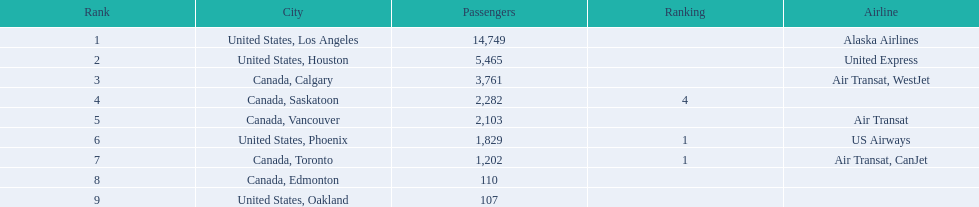What were the total passenger figures? 14,749, 5,465, 3,761, 2,282, 2,103, 1,829, 1,202, 110, 107. Which of these were bound for los angeles? 14,749. What other destination, together with this, is almost 19,000? Canada, Calgary. Which airport has the lowest passenger count? 107. What airport accommodates 107 passengers? United States, Oakland. Could you parse the entire table? {'header': ['Rank', 'City', 'Passengers', 'Ranking', 'Airline'], 'rows': [['1', 'United States, Los Angeles', '14,749', '', 'Alaska Airlines'], ['2', 'United States, Houston', '5,465', '', 'United Express'], ['3', 'Canada, Calgary', '3,761', '', 'Air Transat, WestJet'], ['4', 'Canada, Saskatoon', '2,282', '4', ''], ['5', 'Canada, Vancouver', '2,103', '', 'Air Transat'], ['6', 'United States, Phoenix', '1,829', '1', 'US Airways'], ['7', 'Canada, Toronto', '1,202', '1', 'Air Transat, CanJet'], ['8', 'Canada, Edmonton', '110', '', ''], ['9', 'United States, Oakland', '107', '', '']]} 